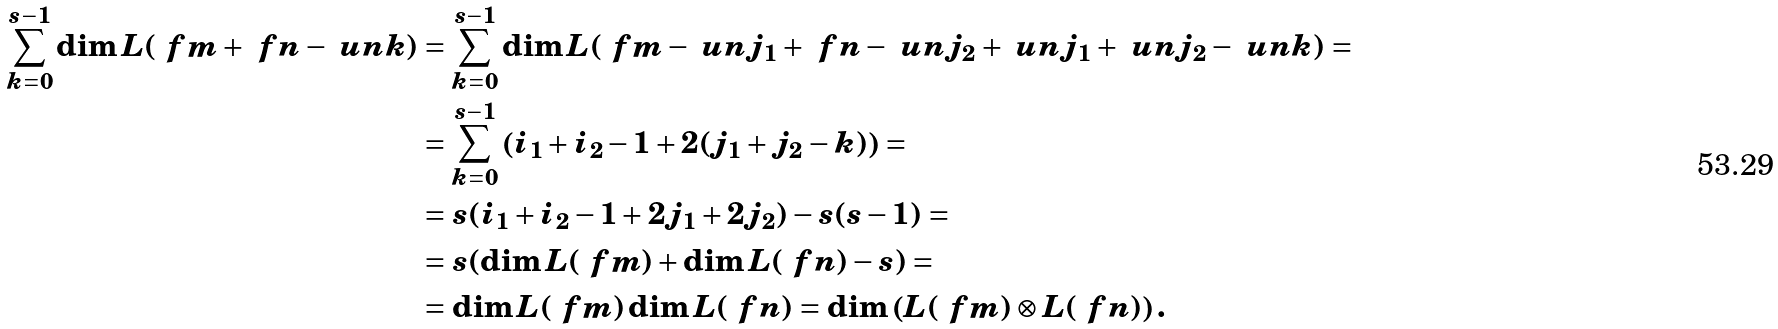Convert formula to latex. <formula><loc_0><loc_0><loc_500><loc_500>\sum _ { k = 0 } ^ { s - 1 } \dim L ( \ f m + \ f n - \ u n { k } ) & = \sum _ { k = 0 } ^ { s - 1 } \dim L ( \ f m - \ u n { j _ { 1 } } + \ f n - \ u n { j _ { 2 } } + \ u n { j _ { 1 } } + \ u n { j _ { 2 } } - \ u n { k } ) = \\ & = \sum _ { k = 0 } ^ { s - 1 } \left ( i _ { 1 } + i _ { 2 } - 1 + 2 ( j _ { 1 } + j _ { 2 } - k ) \right ) = \\ & = s ( i _ { 1 } + i _ { 2 } - 1 + 2 j _ { 1 } + 2 j _ { 2 } ) - s ( s - 1 ) = \\ & = s ( \dim L ( \ f m ) + \dim L ( \ f n ) - s ) = \\ & = \dim L ( \ f m ) \dim L ( \ f n ) = \dim \left ( L ( \ f m ) \otimes L ( \ f n ) \right ) .</formula> 